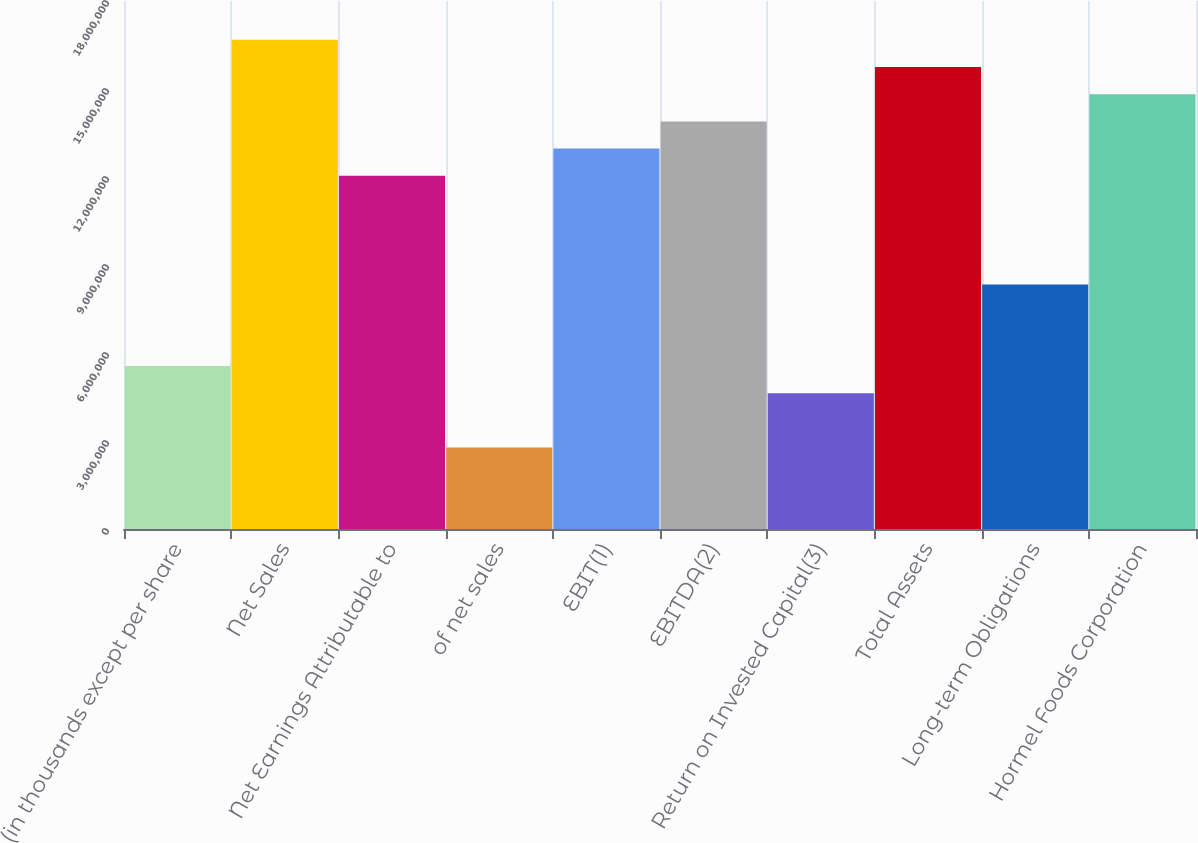Convert chart. <chart><loc_0><loc_0><loc_500><loc_500><bar_chart><fcel>(in thousands except per share<fcel>Net Sales<fcel>Net Earnings Attributable to<fcel>of net sales<fcel>EBIT(1)<fcel>EBITDA(2)<fcel>Return on Invested Capital(3)<fcel>Total Assets<fcel>Long-term Obligations<fcel>Hormel Foods Corporation<nl><fcel>5.55832e+06<fcel>1.6675e+07<fcel>1.2043e+07<fcel>2.77916e+06<fcel>1.29694e+07<fcel>1.38958e+07<fcel>4.63193e+06<fcel>1.57486e+07<fcel>8.33748e+06<fcel>1.48222e+07<nl></chart> 